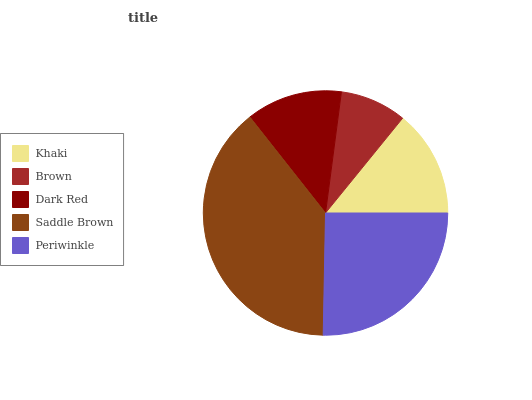Is Brown the minimum?
Answer yes or no. Yes. Is Saddle Brown the maximum?
Answer yes or no. Yes. Is Dark Red the minimum?
Answer yes or no. No. Is Dark Red the maximum?
Answer yes or no. No. Is Dark Red greater than Brown?
Answer yes or no. Yes. Is Brown less than Dark Red?
Answer yes or no. Yes. Is Brown greater than Dark Red?
Answer yes or no. No. Is Dark Red less than Brown?
Answer yes or no. No. Is Khaki the high median?
Answer yes or no. Yes. Is Khaki the low median?
Answer yes or no. Yes. Is Brown the high median?
Answer yes or no. No. Is Brown the low median?
Answer yes or no. No. 